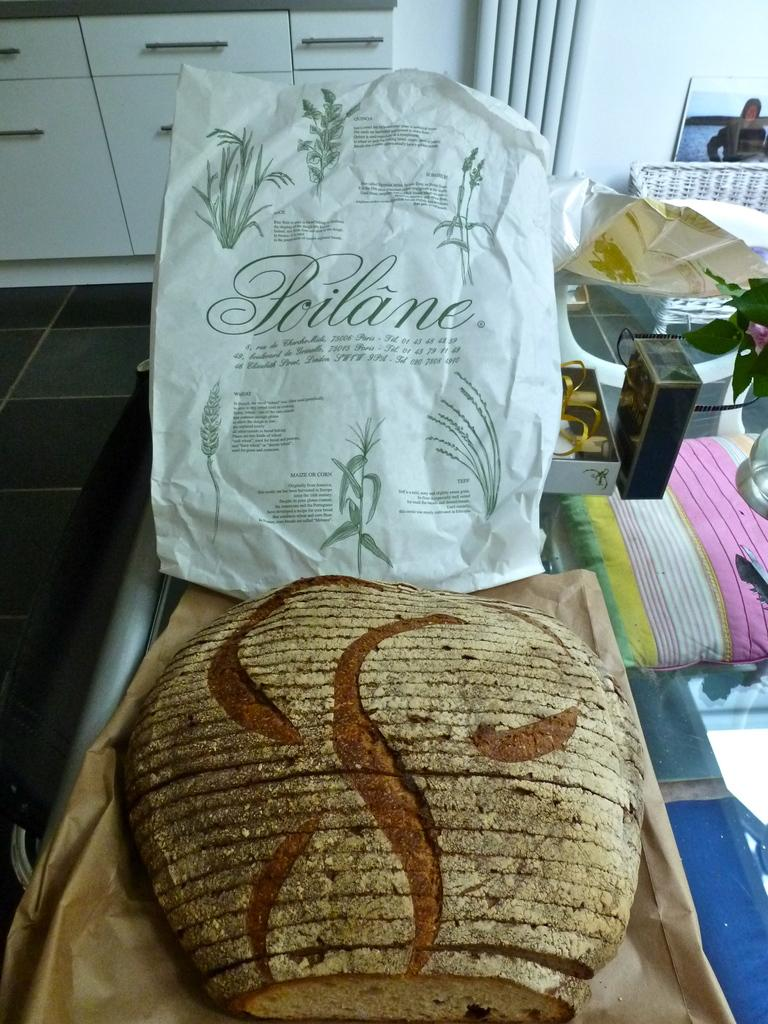What type of items can be seen in the image? There are bags, covers, and a house plant in the image. What is the stand in the image used for? The stand in the image is used to hold other objects, such as the bags and covers. What can be seen in the background of the image? There is a cupboard and a frame on the wall in the background of the image. What type of silk material is draped over the stone statue in the image? There is no silk material or stone statue present in the image. 